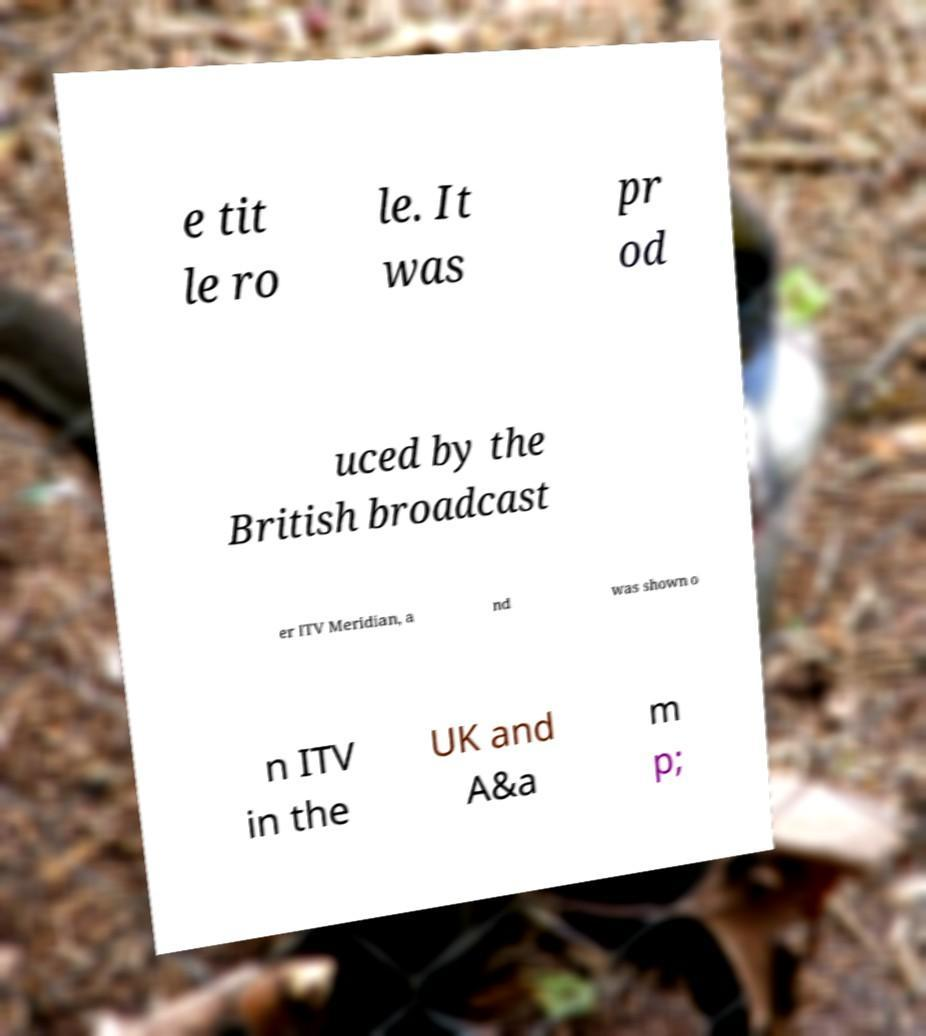Could you assist in decoding the text presented in this image and type it out clearly? e tit le ro le. It was pr od uced by the British broadcast er ITV Meridian, a nd was shown o n ITV in the UK and A&a m p; 